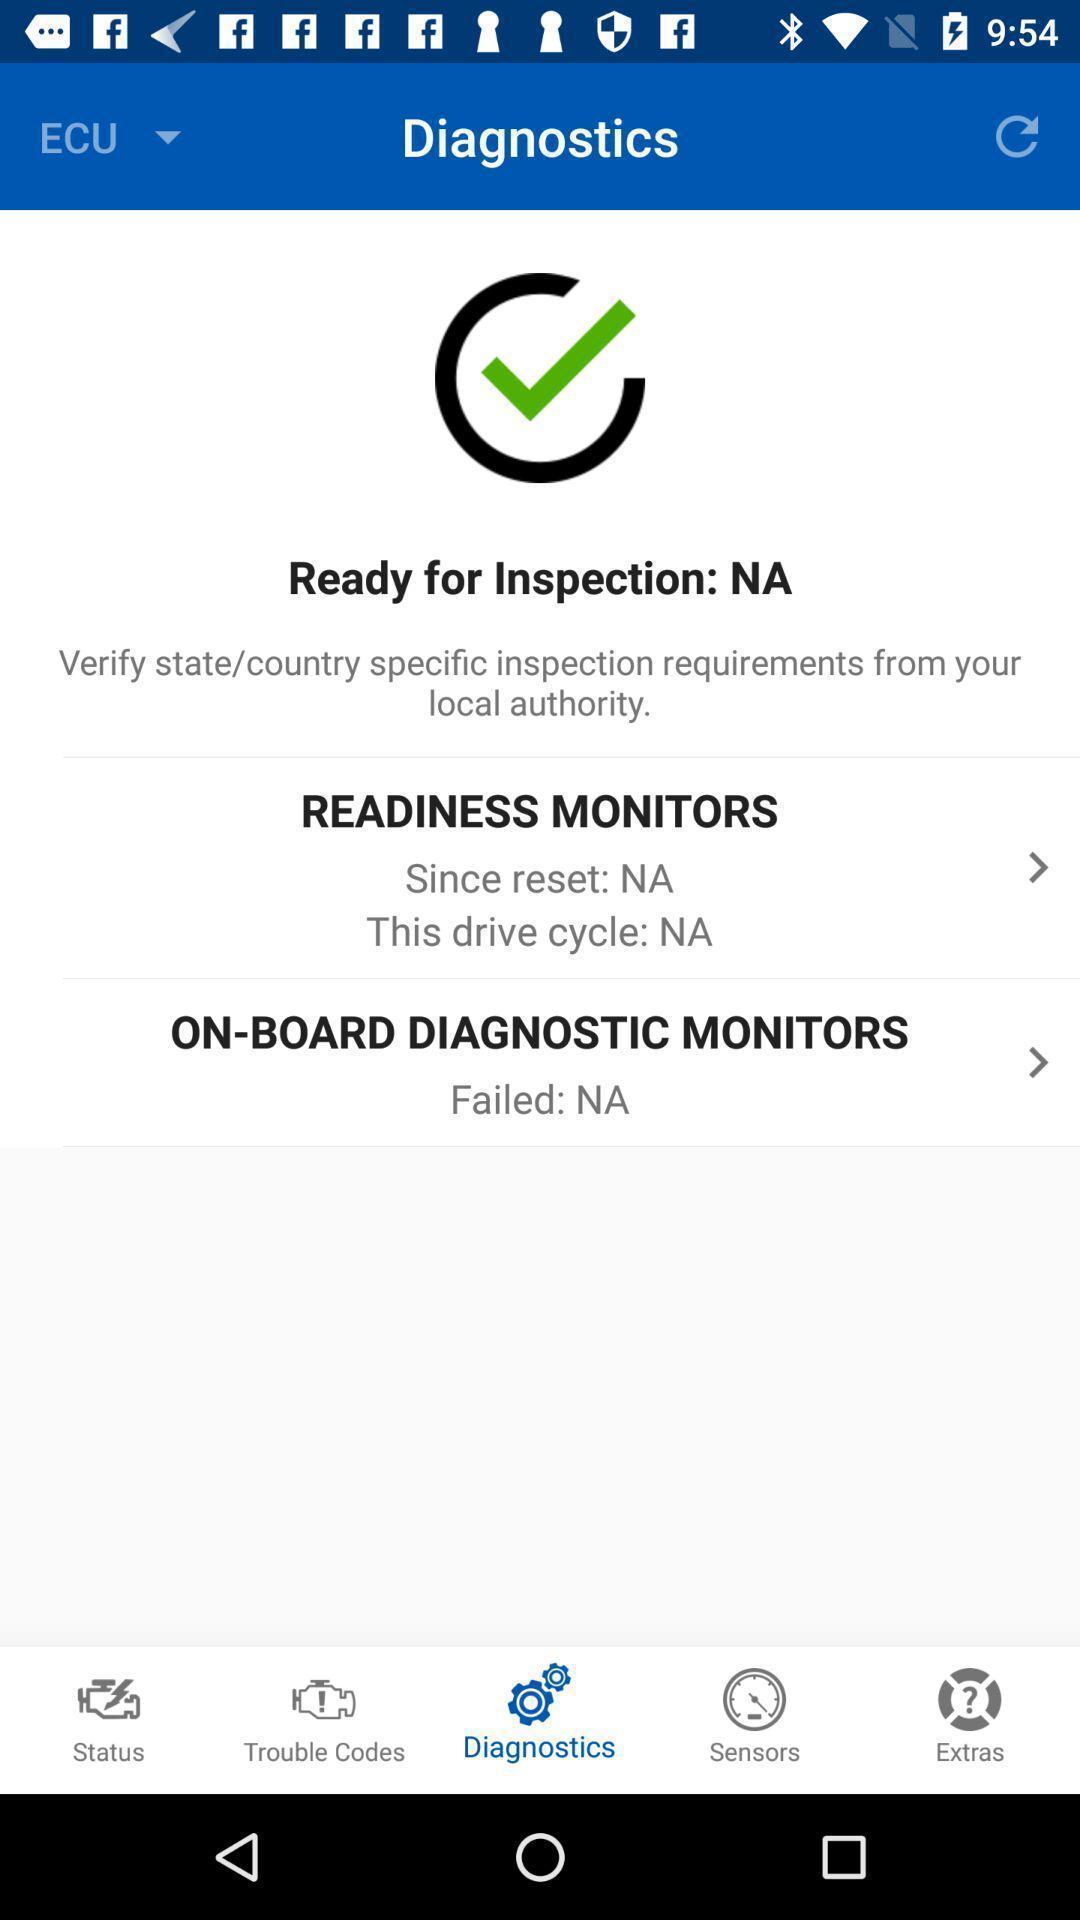Describe the visual elements of this screenshot. Page showing multiple diagnostics. 